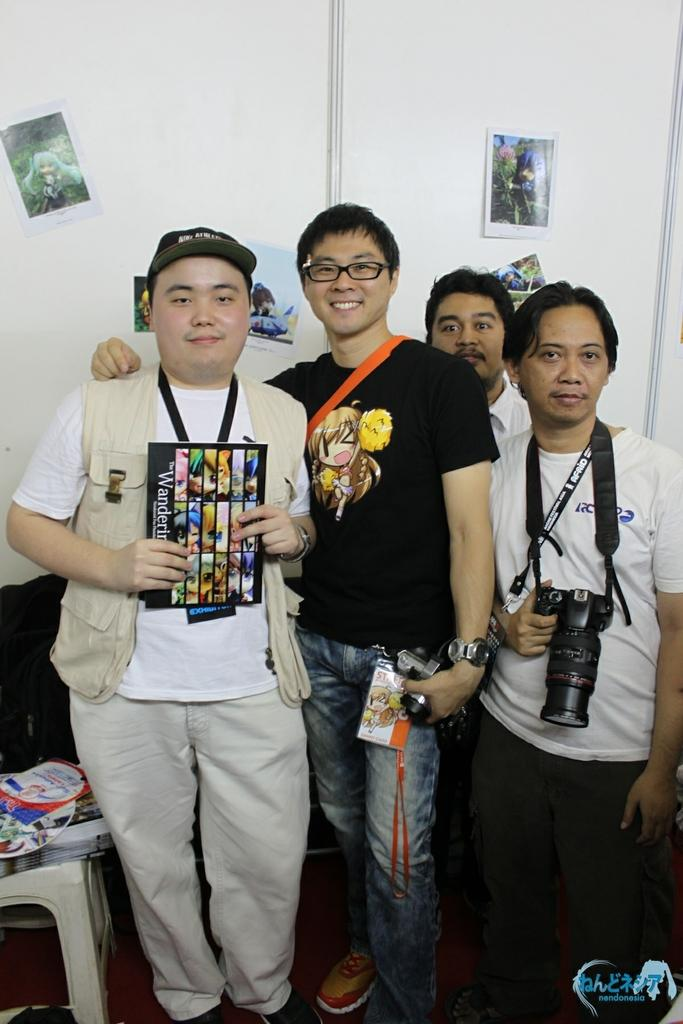How many people are in the picture? There are four members in the picture. What is one of the members doing in the picture? One of the members is holding a camera in his hand. What can be seen on the wall in the background? There are photographs attached to the wall in the background. What type of pies are being served on the table in the image? There is no table or pies present in the image. How does the yarn contribute to the overall composition of the image? There is no yarn present in the image. 